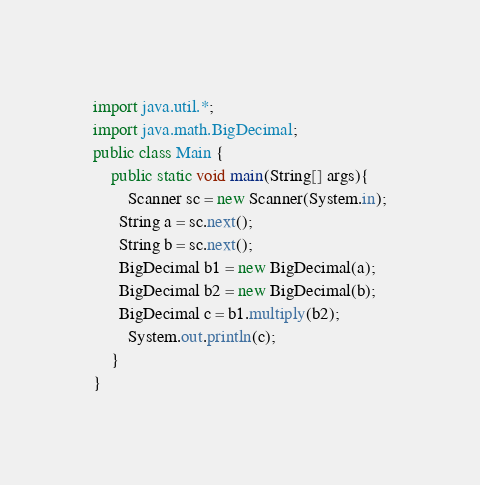<code> <loc_0><loc_0><loc_500><loc_500><_Java_>import java.util.*;
import java.math.BigDecimal;
public class Main {
    public static void main(String[] args){
        Scanner sc = new Scanner(System.in);
      String a = sc.next();
      String b = sc.next();
      BigDecimal b1 = new BigDecimal(a);
      BigDecimal b2 = new BigDecimal(b);
      BigDecimal c = b1.multiply(b2);
        System.out.println(c);
    }
}</code> 